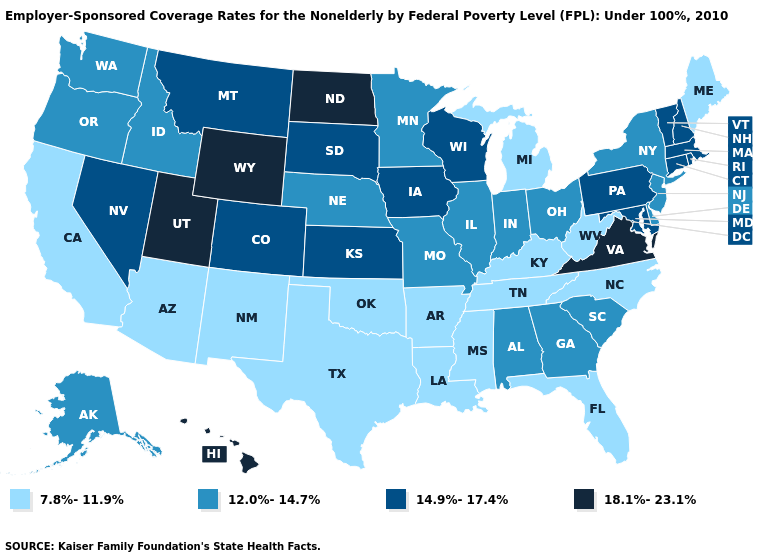What is the lowest value in the Northeast?
Keep it brief. 7.8%-11.9%. Name the states that have a value in the range 14.9%-17.4%?
Give a very brief answer. Colorado, Connecticut, Iowa, Kansas, Maryland, Massachusetts, Montana, Nevada, New Hampshire, Pennsylvania, Rhode Island, South Dakota, Vermont, Wisconsin. What is the value of Rhode Island?
Concise answer only. 14.9%-17.4%. Name the states that have a value in the range 14.9%-17.4%?
Quick response, please. Colorado, Connecticut, Iowa, Kansas, Maryland, Massachusetts, Montana, Nevada, New Hampshire, Pennsylvania, Rhode Island, South Dakota, Vermont, Wisconsin. How many symbols are there in the legend?
Concise answer only. 4. Which states hav the highest value in the West?
Write a very short answer. Hawaii, Utah, Wyoming. How many symbols are there in the legend?
Keep it brief. 4. Name the states that have a value in the range 18.1%-23.1%?
Quick response, please. Hawaii, North Dakota, Utah, Virginia, Wyoming. Name the states that have a value in the range 14.9%-17.4%?
Short answer required. Colorado, Connecticut, Iowa, Kansas, Maryland, Massachusetts, Montana, Nevada, New Hampshire, Pennsylvania, Rhode Island, South Dakota, Vermont, Wisconsin. Among the states that border Indiana , which have the highest value?
Concise answer only. Illinois, Ohio. Does North Dakota have the highest value in the USA?
Short answer required. Yes. Does Idaho have a lower value than Pennsylvania?
Answer briefly. Yes. Does Florida have the lowest value in the South?
Write a very short answer. Yes. Among the states that border Utah , which have the lowest value?
Give a very brief answer. Arizona, New Mexico. What is the lowest value in states that border Oregon?
Short answer required. 7.8%-11.9%. 